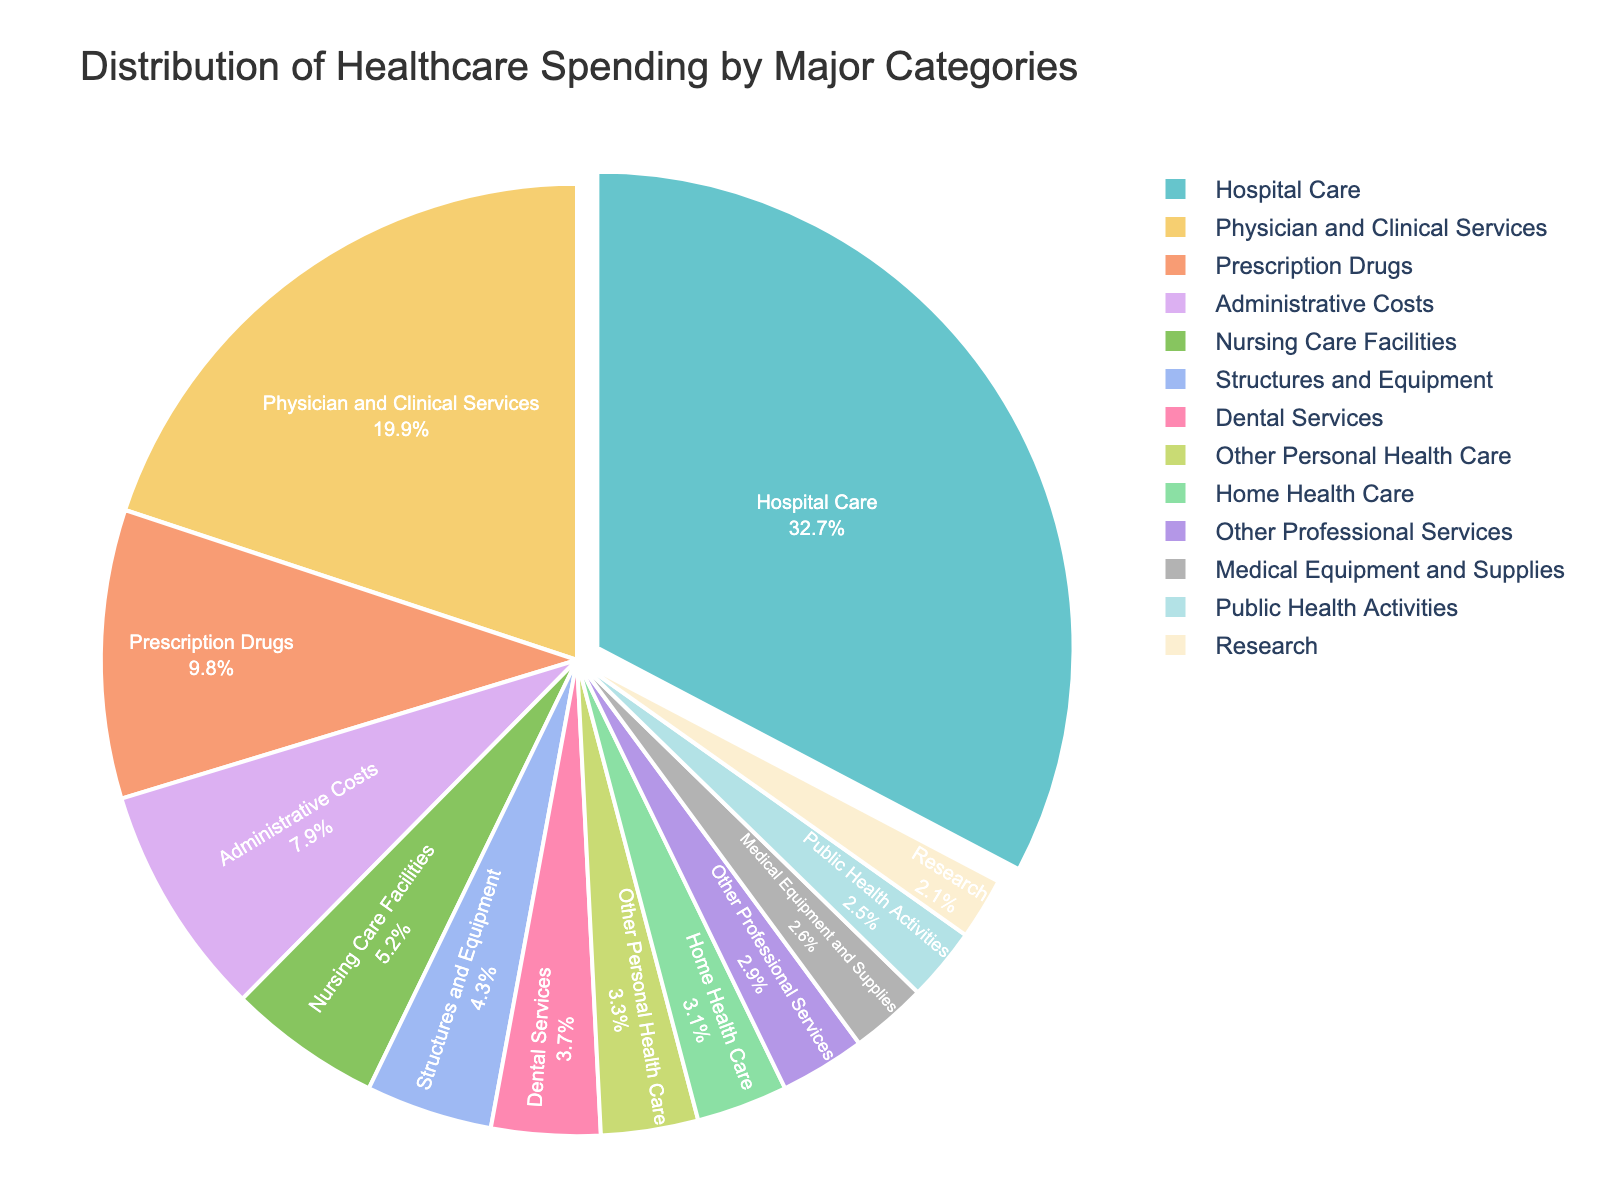What category has the highest percentage of healthcare spending? The pie chart shows various categories of healthcare spending with their respective percentages. By looking at the slices, the 'Hospital Care' category has the largest section, indicated by 32.7%.
Answer: Hospital Care What are the categories with the lowest percentages of healthcare spending? To find the categories with the lowest percentages, we look for the smallest slices in the pie chart. The smallest percentages are for 'Other Professional Services' (2.9%), 'Medical Equipment and Supplies' (2.6%), 'Public Health Activities' (2.5%), and 'Research' (2.1%).
Answer: Other Professional Services, Medical Equipment and Supplies, Public Health Activities, Research How much more is spent on Hospital Care compared to Physician and Clinical Services? 'Hospital Care' has 32.7% of the spending, while 'Physician and Clinical Services' has 19.9%. To find the difference, subtract 19.9 from 32.7, which gives 12.8.
Answer: 12.8% What is the combined spending percentage for Prescription Drugs and Nursing Care Facilities? Prescription Drugs account for 9.8% and Nursing Care Facilities for 5.2%. Adding these percentages together gives 9.8 + 5.2 = 15.
Answer: 15% Which categories combined together approximate 10% of the healthcare spending? Looking at the individual percentages, 'Home Health Care' (3.1%) and 'Dental Services' (3.7%) sum to 6.8%, while 'Home Health Care' (3.1%) and 'Other Personal Health Care' (3.3%) sum to 6.4%. The closest combination to 10% is 'Nursing Care Facilities' (5.2%) and 'Dental Services' (3.7%), which sum to 8.9%. Adding 'Other Professional Services' (2.9%) to 'Home Health Care' (3.1%) gives 6%. Thus, some accurate combinations can be challenging to pinpoint but the nearest would be 'Nursing Care Facilities' and 'Dental Services' together.
Answer: Nursing Care Facilities, Dental Services Which category has a larger share of spending: Administrative Costs or Structures and Equipment? The pie chart shows that 'Administrative Costs' account for 7.9% of healthcare spending, whereas 'Structures and Equipment' account for 4.3%. Comparing these two, the 'Administrative Costs' category has a larger share.
Answer: Administrative Costs Is the spending on Prescription Drugs greater than the combined spending on Dental Services and Home Health Care? Prescription Drugs account for 9.8%. The combined spending for Dental Services (3.7%) and Home Health Care (3.1%) is 3.7 + 3.1 = 6.8%. Since 9.8% is greater than 6.8%, the spending on Prescription Drugs is indeed greater.
Answer: Yes What is the percentage difference between the highest and lowest spending categories? The highest spending category is 'Hospital Care' at 32.7%, and the lowest is 'Research' at 2.1%. Subtracting 2.1 from 32.7 gives 30.6.
Answer: 30.6% How much more is spent on Physician and Clinical Services compared to Public Health Activities? 'Physician and Clinical Services' have 19.9%, while 'Public Health Activities' have 2.5%. Subtracting 2.5 from 19.9 results in 17.4.
Answer: 17.4% Which category is pulled out slightly in the pie chart to emphasize its importance? The pie chart emphasizes categories by pulling them slightly out. 'Hospital Care', accounting for the highest spending at 32.7%, is the category that is pulled out in the pie chart.
Answer: Hospital Care 